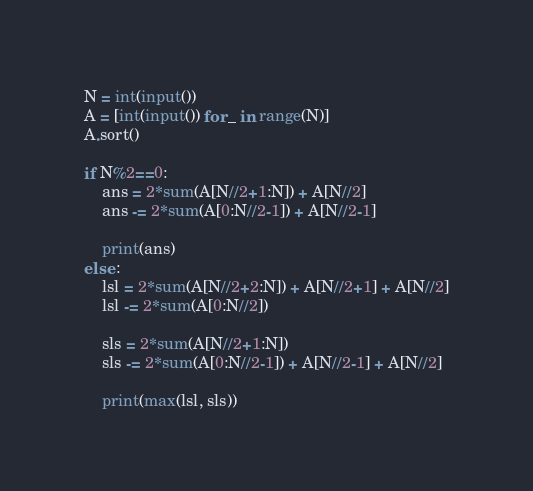Convert code to text. <code><loc_0><loc_0><loc_500><loc_500><_Python_>N = int(input())
A = [int(input()) for _ in range(N)]
A.sort()

if N%2==0: 
    ans = 2*sum(A[N//2+1:N]) + A[N//2]
    ans -= 2*sum(A[0:N//2-1]) + A[N//2-1]

    print(ans)
else :
    lsl = 2*sum(A[N//2+2:N]) + A[N//2+1] + A[N//2]
    lsl -= 2*sum(A[0:N//2])

    sls = 2*sum(A[N//2+1:N])
    sls -= 2*sum(A[0:N//2-1]) + A[N//2-1] + A[N//2]

    print(max(lsl, sls))</code> 